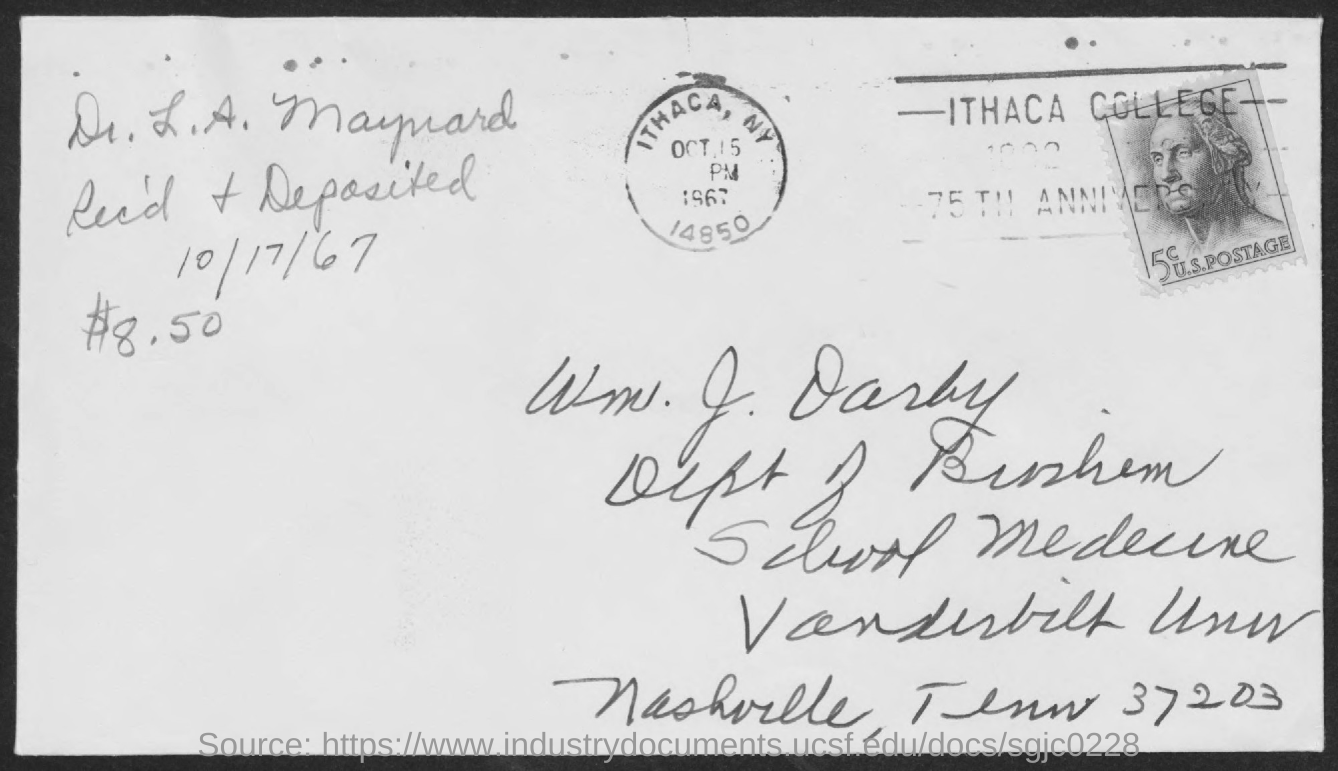When was received and deposited?
Provide a short and direct response. 10/17/67. What amount was received and deposited?
Your answer should be very brief. 8.50. Where is it postmarked?
Offer a very short reply. ITHACA, NY. 